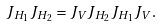Convert formula to latex. <formula><loc_0><loc_0><loc_500><loc_500>J _ { H _ { 1 } } J _ { H _ { 2 } } = J _ { V } J _ { H _ { 2 } } J _ { H _ { 1 } } J _ { V } .</formula> 